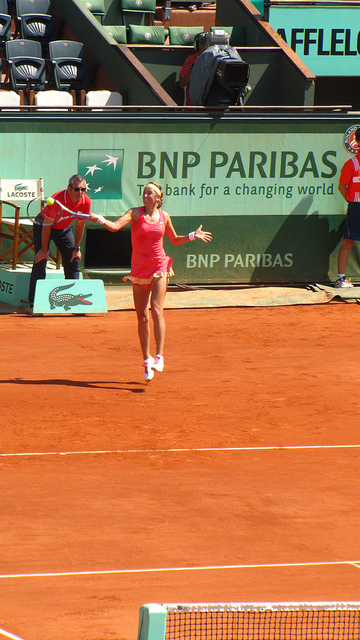Please extract the text content from this image. BNP PARIBAS BNP PARIBAS bank for AFFLEL STE world changing a LACOSTE 